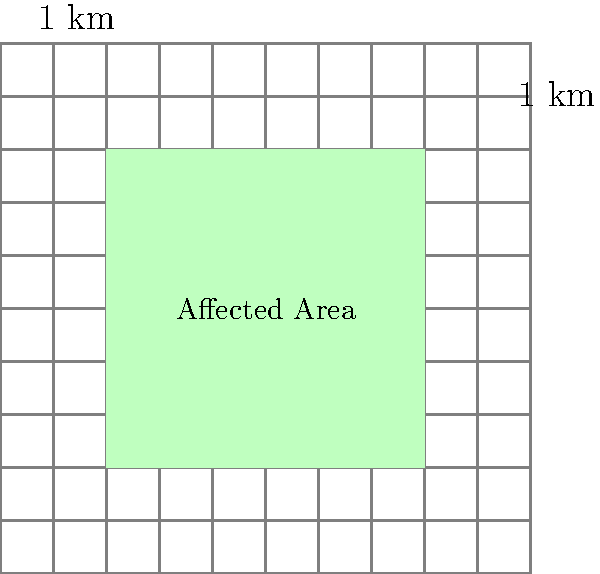A tectonic event has caused deforestation in a rectangular area as shown on the map above. Each grid square represents 1 square kilometer. Calculate the total surface area affected by deforestation due to this tectonic activity. To calculate the surface area affected by deforestation, we need to follow these steps:

1. Identify the shape of the affected area:
   The affected area is a rectangle on the grid.

2. Determine the dimensions of the rectangle:
   - Width: The rectangle spans 6 grid squares horizontally.
   - Height: The rectangle spans 6 grid squares vertically.

3. Calculate the area using the formula for a rectangle:
   Area = width × height
   
   Since each grid square represents 1 square kilometer:
   Area = 6 km × 6 km = 36 km²

Therefore, the total surface area affected by deforestation due to tectonic activity is 36 square kilometers.
Answer: 36 km² 